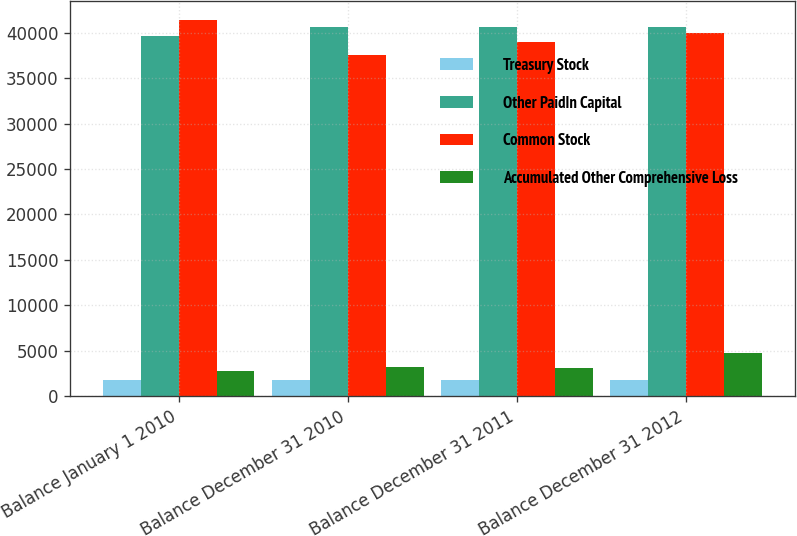<chart> <loc_0><loc_0><loc_500><loc_500><stacked_bar_chart><ecel><fcel>Balance January 1 2010<fcel>Balance December 31 2010<fcel>Balance December 31 2011<fcel>Balance December 31 2012<nl><fcel>Treasury Stock<fcel>1781<fcel>1788<fcel>1788<fcel>1788<nl><fcel>Other PaidIn Capital<fcel>39683<fcel>40701<fcel>40663<fcel>40646<nl><fcel>Common Stock<fcel>41405<fcel>37536<fcel>38990<fcel>39985<nl><fcel>Accumulated Other Comprehensive Loss<fcel>2767<fcel>3216<fcel>3132<fcel>4682<nl></chart> 